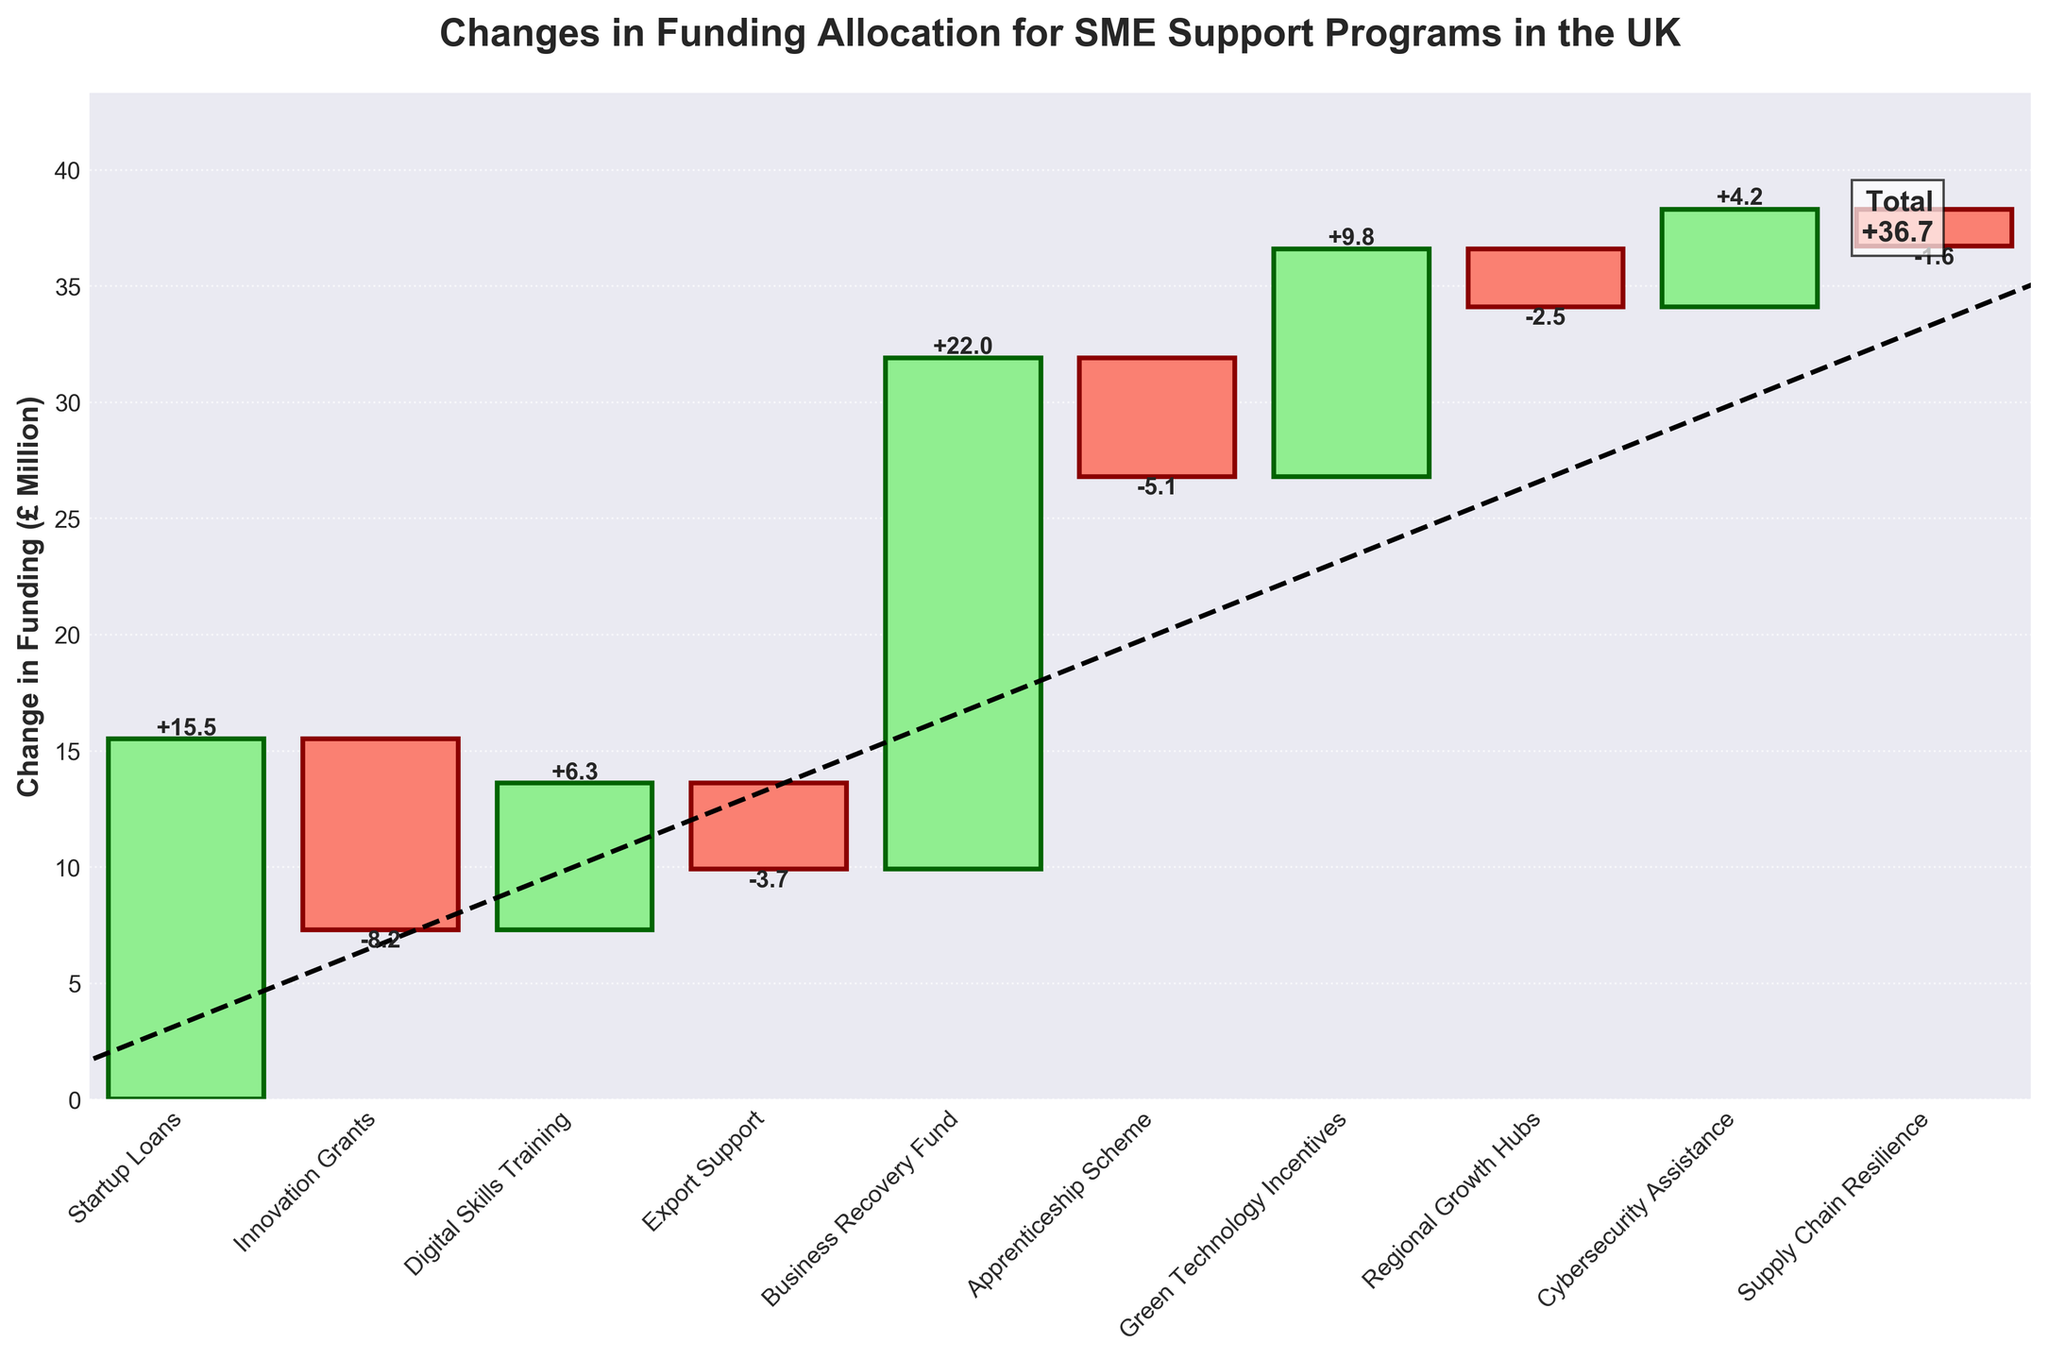Which SME support program had the highest increase in funding? Locate the bar with the largest positive value. The tallest green bar represents the "Business Recovery Fund" with a +22.0 change.
Answer: Business Recovery Fund Which category saw the largest decrease in funding? Find the bar with the largest negative value. The tallest red bar is "Innovation Grants" with a -8.2 change.
Answer: Innovation Grants What is the title of the chart? Read the text at the top of the chart.
Answer: Changes in Funding Allocation for SME Support Programs in the UK How many categories have an increase in funding? Count the number of green bars representing positive changes. There are six green bars indicating increases.
Answer: 6 How many categories have a decrease in funding? Count the number of red bars representing negative changes. There are four red bars indicating decreases.
Answer: 4 What is the change in funding for the "Digital Skills Training" category? Look for "Digital Skills Training" on the x-axis and find the corresponding bar. The value label shows a +6.3 change.
Answer: +6.3 What is the cumulative funding change after considering the "Apprenticeship Scheme"? Add up the changes for all categories up to "Apprenticeship Scheme." 
The cumulative calculation is: 
15.5 (Startup Loans) - 8.2 (Innovation Grants) + 6.3 (Digital Skills Training) - 3.7 (Export Support) + 22.0 (Business Recovery Fund) - 5.1 (Apprenticeship Scheme) = 26.8.
Answer: 26.8 Which categories have a funding change greater than +5? Find categories where the bars and their labels show values greater than +5. These are "Startup Loans" (+15.5), "Digital Skills Training" (+6.3), "Business Recovery Fund" (+22.0), and "Green Technology Incentives" (+9.8).
Answer: Startup Loans, Digital Skills Training, Business Recovery Fund, Green Technology Incentives What is the total change in funding across all categories? Sum all individual funding changes. The values add up to be:
15.5 - 8.2 + 6.3 - 3.7 + 22.0 - 5.1 + 9.8 - 2.5 + 4.2 - 1.6 = 36.7.
Answer: 36.7 Is the change in funding for "Cybersecurity Assistance" positive or negative? Look at the value label for "Cybersecurity Assistance." The label shows +4.2, which indicates a positive change.
Answer: Positive 